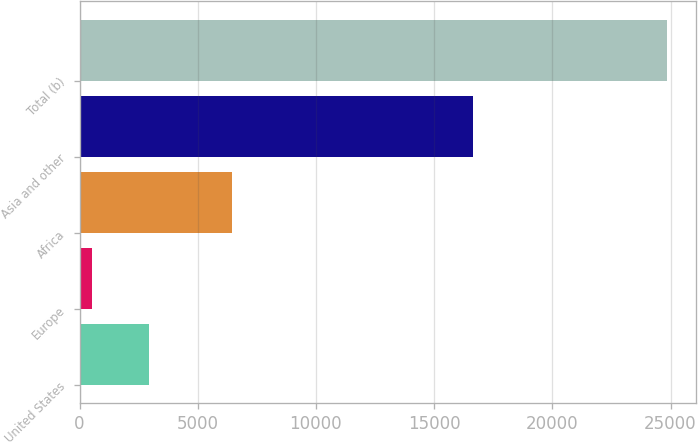Convert chart. <chart><loc_0><loc_0><loc_500><loc_500><bar_chart><fcel>United States<fcel>Europe<fcel>Africa<fcel>Asia and other<fcel>Total (b)<nl><fcel>2958.5<fcel>528<fcel>6433<fcel>16655<fcel>24833<nl></chart> 